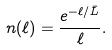Convert formula to latex. <formula><loc_0><loc_0><loc_500><loc_500>n ( \ell ) = { \frac { e ^ { - \ell / { \bar { L } } } } { \ell } } .</formula> 